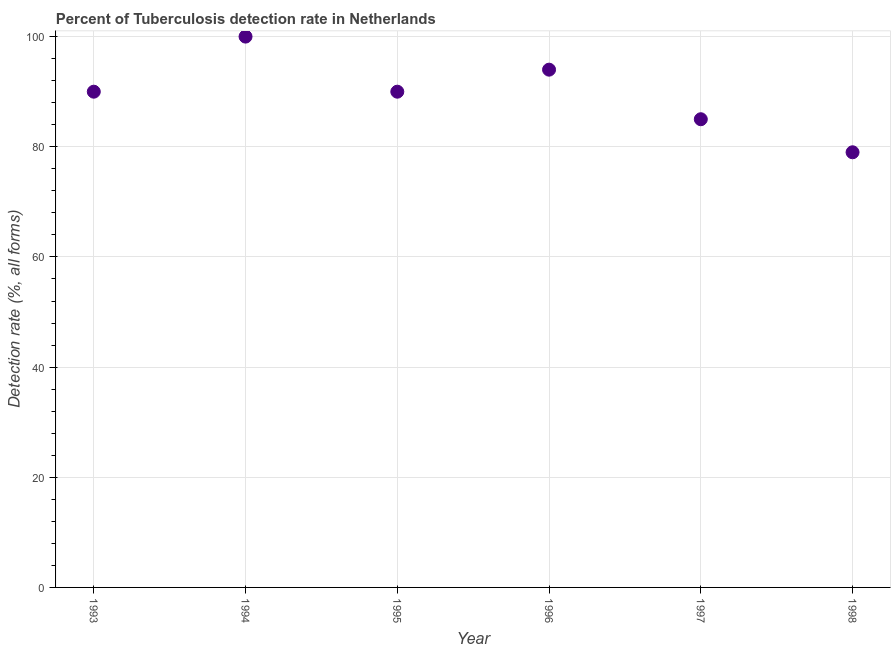What is the detection rate of tuberculosis in 1994?
Your answer should be compact. 100. Across all years, what is the maximum detection rate of tuberculosis?
Provide a succinct answer. 100. Across all years, what is the minimum detection rate of tuberculosis?
Make the answer very short. 79. In which year was the detection rate of tuberculosis minimum?
Keep it short and to the point. 1998. What is the sum of the detection rate of tuberculosis?
Provide a succinct answer. 538. What is the difference between the detection rate of tuberculosis in 1993 and 1998?
Your response must be concise. 11. What is the average detection rate of tuberculosis per year?
Make the answer very short. 89.67. What is the median detection rate of tuberculosis?
Offer a very short reply. 90. What is the ratio of the detection rate of tuberculosis in 1994 to that in 1997?
Your response must be concise. 1.18. Is the difference between the detection rate of tuberculosis in 1993 and 1996 greater than the difference between any two years?
Your response must be concise. No. What is the difference between the highest and the second highest detection rate of tuberculosis?
Your answer should be very brief. 6. Is the sum of the detection rate of tuberculosis in 1993 and 1995 greater than the maximum detection rate of tuberculosis across all years?
Keep it short and to the point. Yes. What is the difference between the highest and the lowest detection rate of tuberculosis?
Your response must be concise. 21. In how many years, is the detection rate of tuberculosis greater than the average detection rate of tuberculosis taken over all years?
Your response must be concise. 4. What is the difference between two consecutive major ticks on the Y-axis?
Your answer should be very brief. 20. Are the values on the major ticks of Y-axis written in scientific E-notation?
Offer a terse response. No. Does the graph contain any zero values?
Provide a short and direct response. No. What is the title of the graph?
Offer a terse response. Percent of Tuberculosis detection rate in Netherlands. What is the label or title of the X-axis?
Offer a very short reply. Year. What is the label or title of the Y-axis?
Make the answer very short. Detection rate (%, all forms). What is the Detection rate (%, all forms) in 1993?
Your answer should be compact. 90. What is the Detection rate (%, all forms) in 1996?
Your answer should be compact. 94. What is the Detection rate (%, all forms) in 1997?
Your response must be concise. 85. What is the Detection rate (%, all forms) in 1998?
Ensure brevity in your answer.  79. What is the difference between the Detection rate (%, all forms) in 1993 and 1995?
Make the answer very short. 0. What is the difference between the Detection rate (%, all forms) in 1993 and 1997?
Keep it short and to the point. 5. What is the difference between the Detection rate (%, all forms) in 1993 and 1998?
Make the answer very short. 11. What is the difference between the Detection rate (%, all forms) in 1995 and 1998?
Provide a short and direct response. 11. What is the difference between the Detection rate (%, all forms) in 1996 and 1997?
Offer a terse response. 9. What is the ratio of the Detection rate (%, all forms) in 1993 to that in 1994?
Provide a short and direct response. 0.9. What is the ratio of the Detection rate (%, all forms) in 1993 to that in 1995?
Your response must be concise. 1. What is the ratio of the Detection rate (%, all forms) in 1993 to that in 1997?
Give a very brief answer. 1.06. What is the ratio of the Detection rate (%, all forms) in 1993 to that in 1998?
Provide a short and direct response. 1.14. What is the ratio of the Detection rate (%, all forms) in 1994 to that in 1995?
Your answer should be compact. 1.11. What is the ratio of the Detection rate (%, all forms) in 1994 to that in 1996?
Provide a succinct answer. 1.06. What is the ratio of the Detection rate (%, all forms) in 1994 to that in 1997?
Your answer should be compact. 1.18. What is the ratio of the Detection rate (%, all forms) in 1994 to that in 1998?
Keep it short and to the point. 1.27. What is the ratio of the Detection rate (%, all forms) in 1995 to that in 1996?
Your answer should be very brief. 0.96. What is the ratio of the Detection rate (%, all forms) in 1995 to that in 1997?
Your answer should be compact. 1.06. What is the ratio of the Detection rate (%, all forms) in 1995 to that in 1998?
Provide a short and direct response. 1.14. What is the ratio of the Detection rate (%, all forms) in 1996 to that in 1997?
Offer a terse response. 1.11. What is the ratio of the Detection rate (%, all forms) in 1996 to that in 1998?
Give a very brief answer. 1.19. What is the ratio of the Detection rate (%, all forms) in 1997 to that in 1998?
Keep it short and to the point. 1.08. 